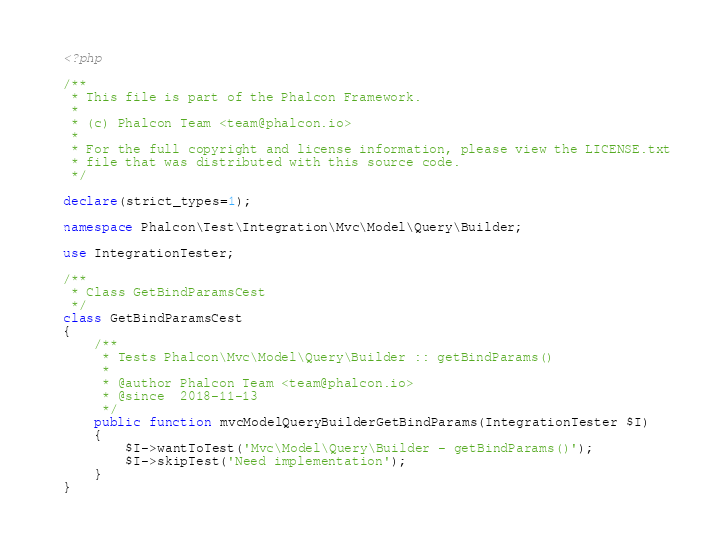Convert code to text. <code><loc_0><loc_0><loc_500><loc_500><_PHP_><?php

/**
 * This file is part of the Phalcon Framework.
 *
 * (c) Phalcon Team <team@phalcon.io>
 *
 * For the full copyright and license information, please view the LICENSE.txt
 * file that was distributed with this source code.
 */

declare(strict_types=1);

namespace Phalcon\Test\Integration\Mvc\Model\Query\Builder;

use IntegrationTester;

/**
 * Class GetBindParamsCest
 */
class GetBindParamsCest
{
    /**
     * Tests Phalcon\Mvc\Model\Query\Builder :: getBindParams()
     *
     * @author Phalcon Team <team@phalcon.io>
     * @since  2018-11-13
     */
    public function mvcModelQueryBuilderGetBindParams(IntegrationTester $I)
    {
        $I->wantToTest('Mvc\Model\Query\Builder - getBindParams()');
        $I->skipTest('Need implementation');
    }
}
</code> 